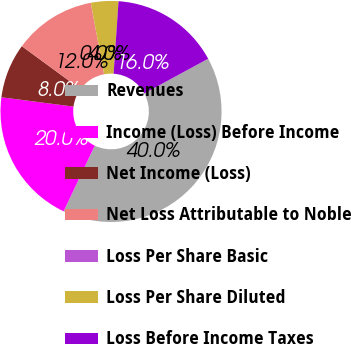Convert chart. <chart><loc_0><loc_0><loc_500><loc_500><pie_chart><fcel>Revenues<fcel>Income (Loss) Before Income<fcel>Net Income (Loss)<fcel>Net Loss Attributable to Noble<fcel>Loss Per Share Basic<fcel>Loss Per Share Diluted<fcel>Loss Before Income Taxes<nl><fcel>39.97%<fcel>19.99%<fcel>8.01%<fcel>12.0%<fcel>0.01%<fcel>4.01%<fcel>16.0%<nl></chart> 